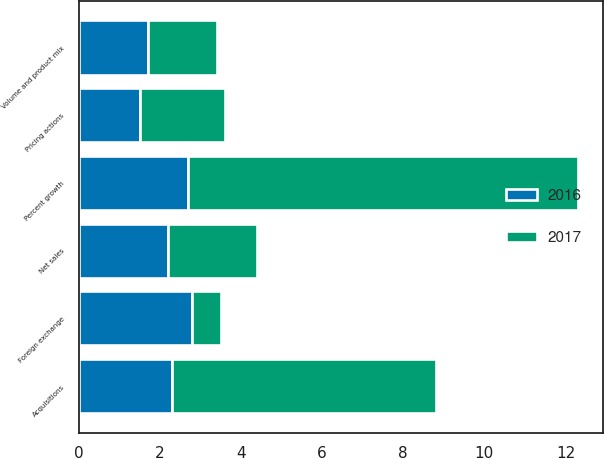<chart> <loc_0><loc_0><loc_500><loc_500><stacked_bar_chart><ecel><fcel>Net sales<fcel>Percent growth<fcel>Volume and product mix<fcel>Pricing actions<fcel>Acquisitions<fcel>Foreign exchange<nl><fcel>2017<fcel>2.2<fcel>9.6<fcel>1.7<fcel>2.1<fcel>6.5<fcel>0.7<nl><fcel>2016<fcel>2.2<fcel>2.7<fcel>1.7<fcel>1.5<fcel>2.3<fcel>2.8<nl></chart> 